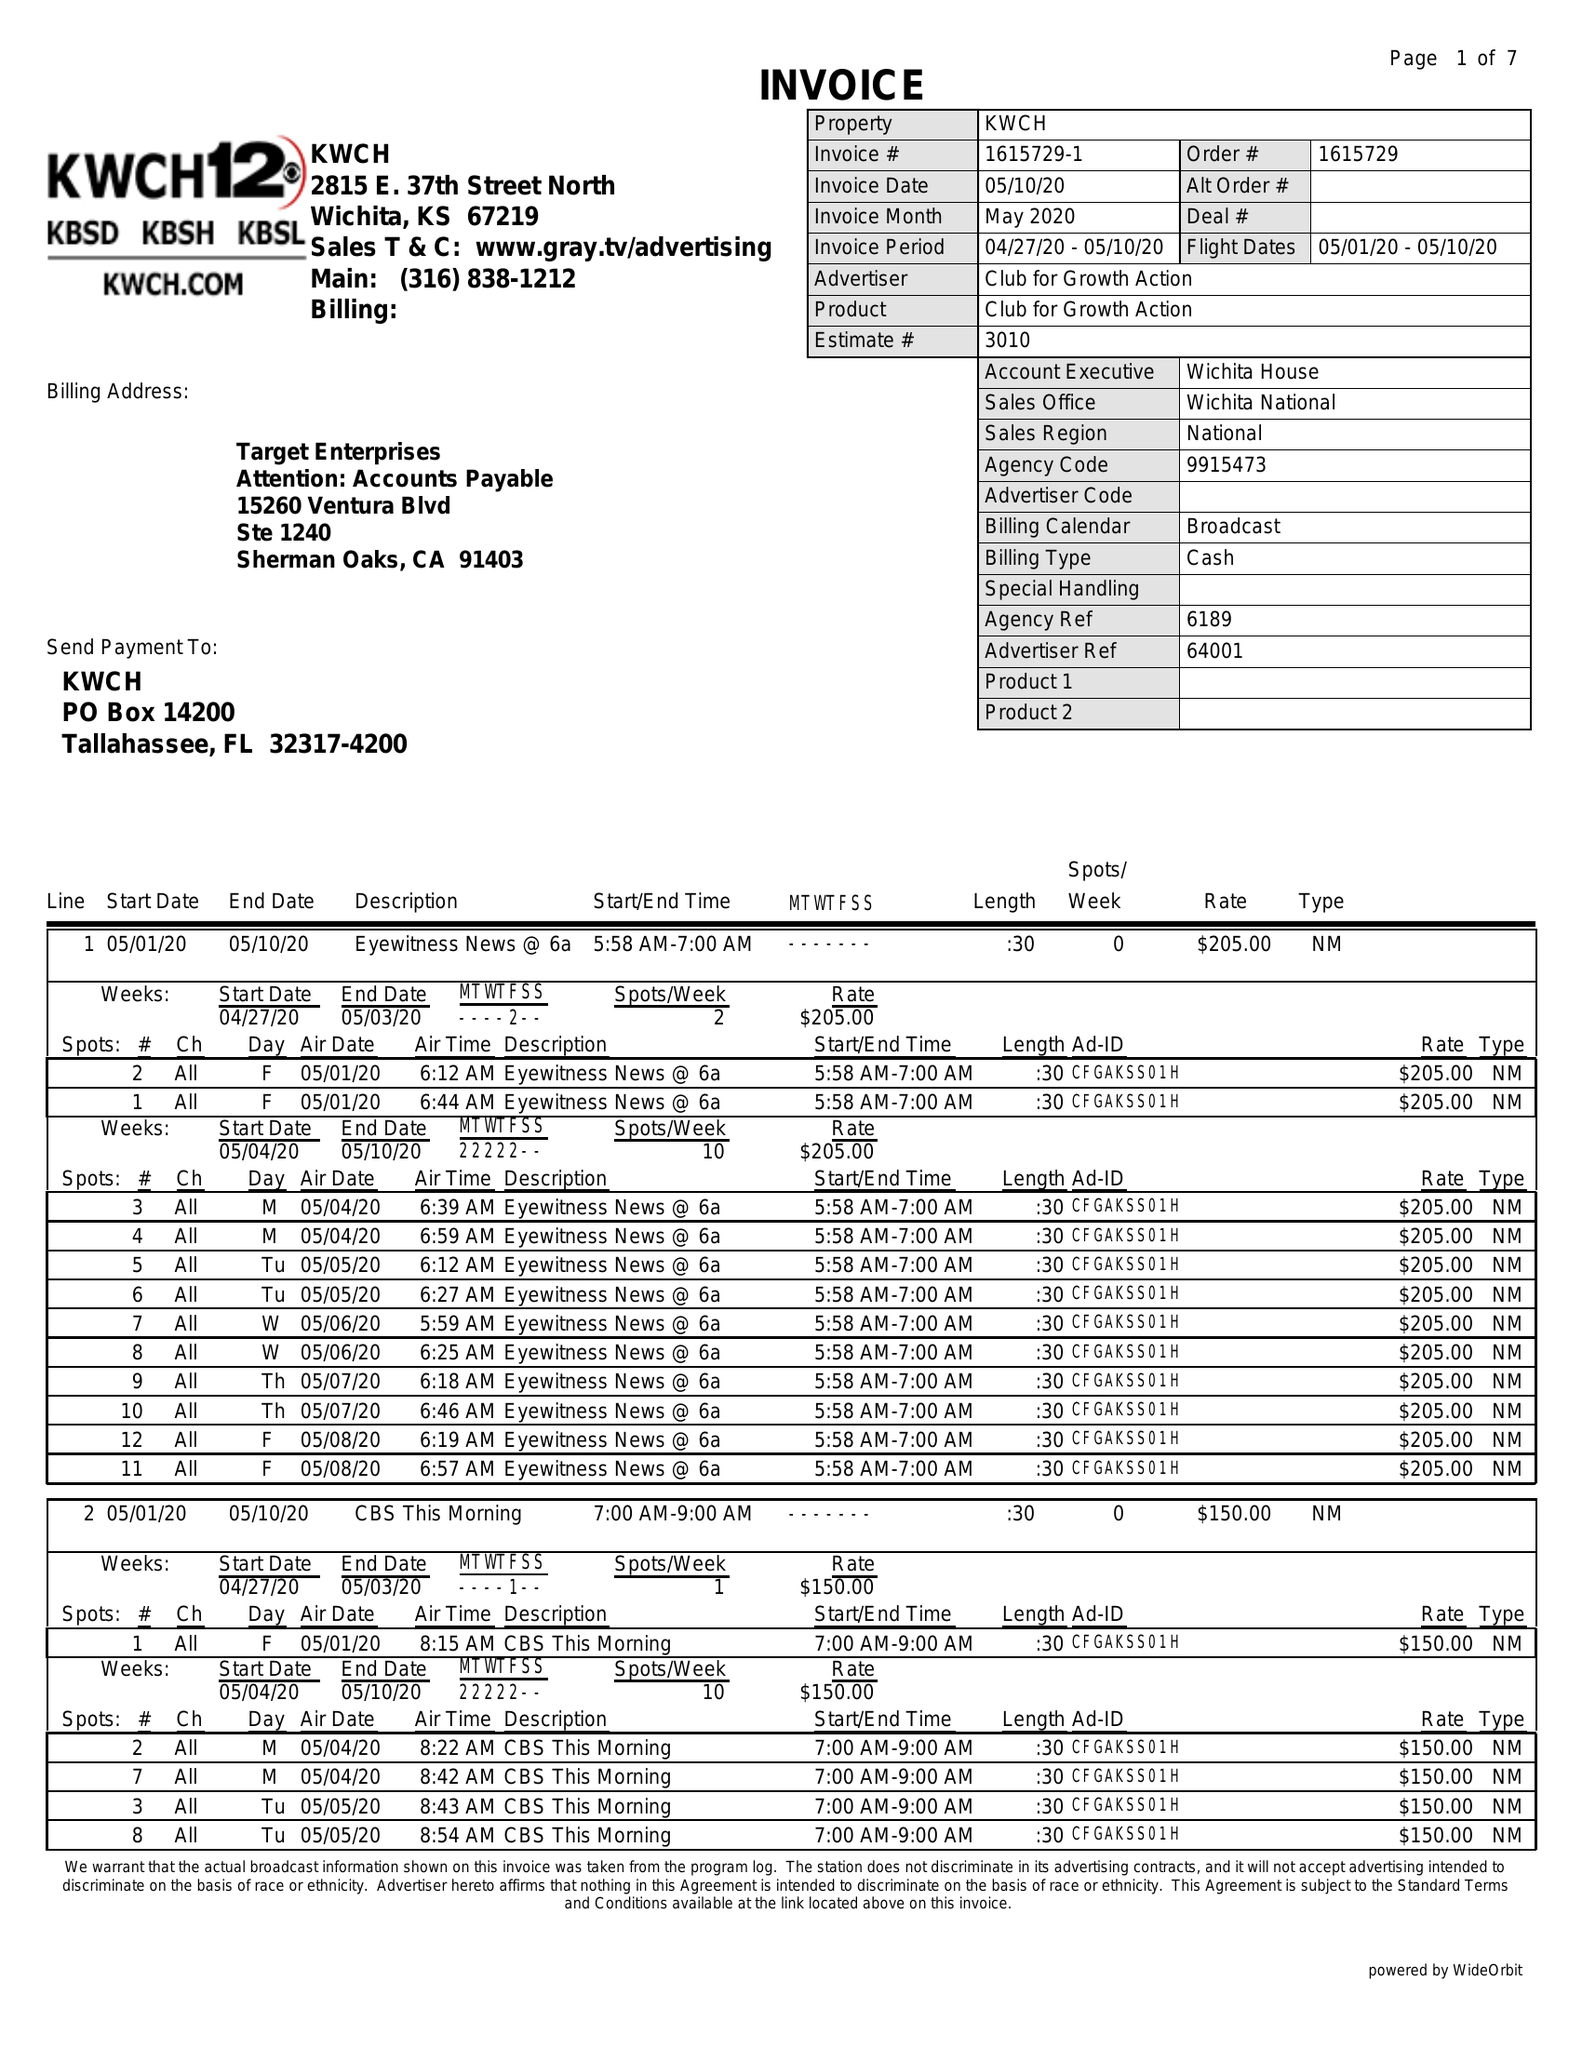What is the value for the flight_from?
Answer the question using a single word or phrase. 05/01/20 